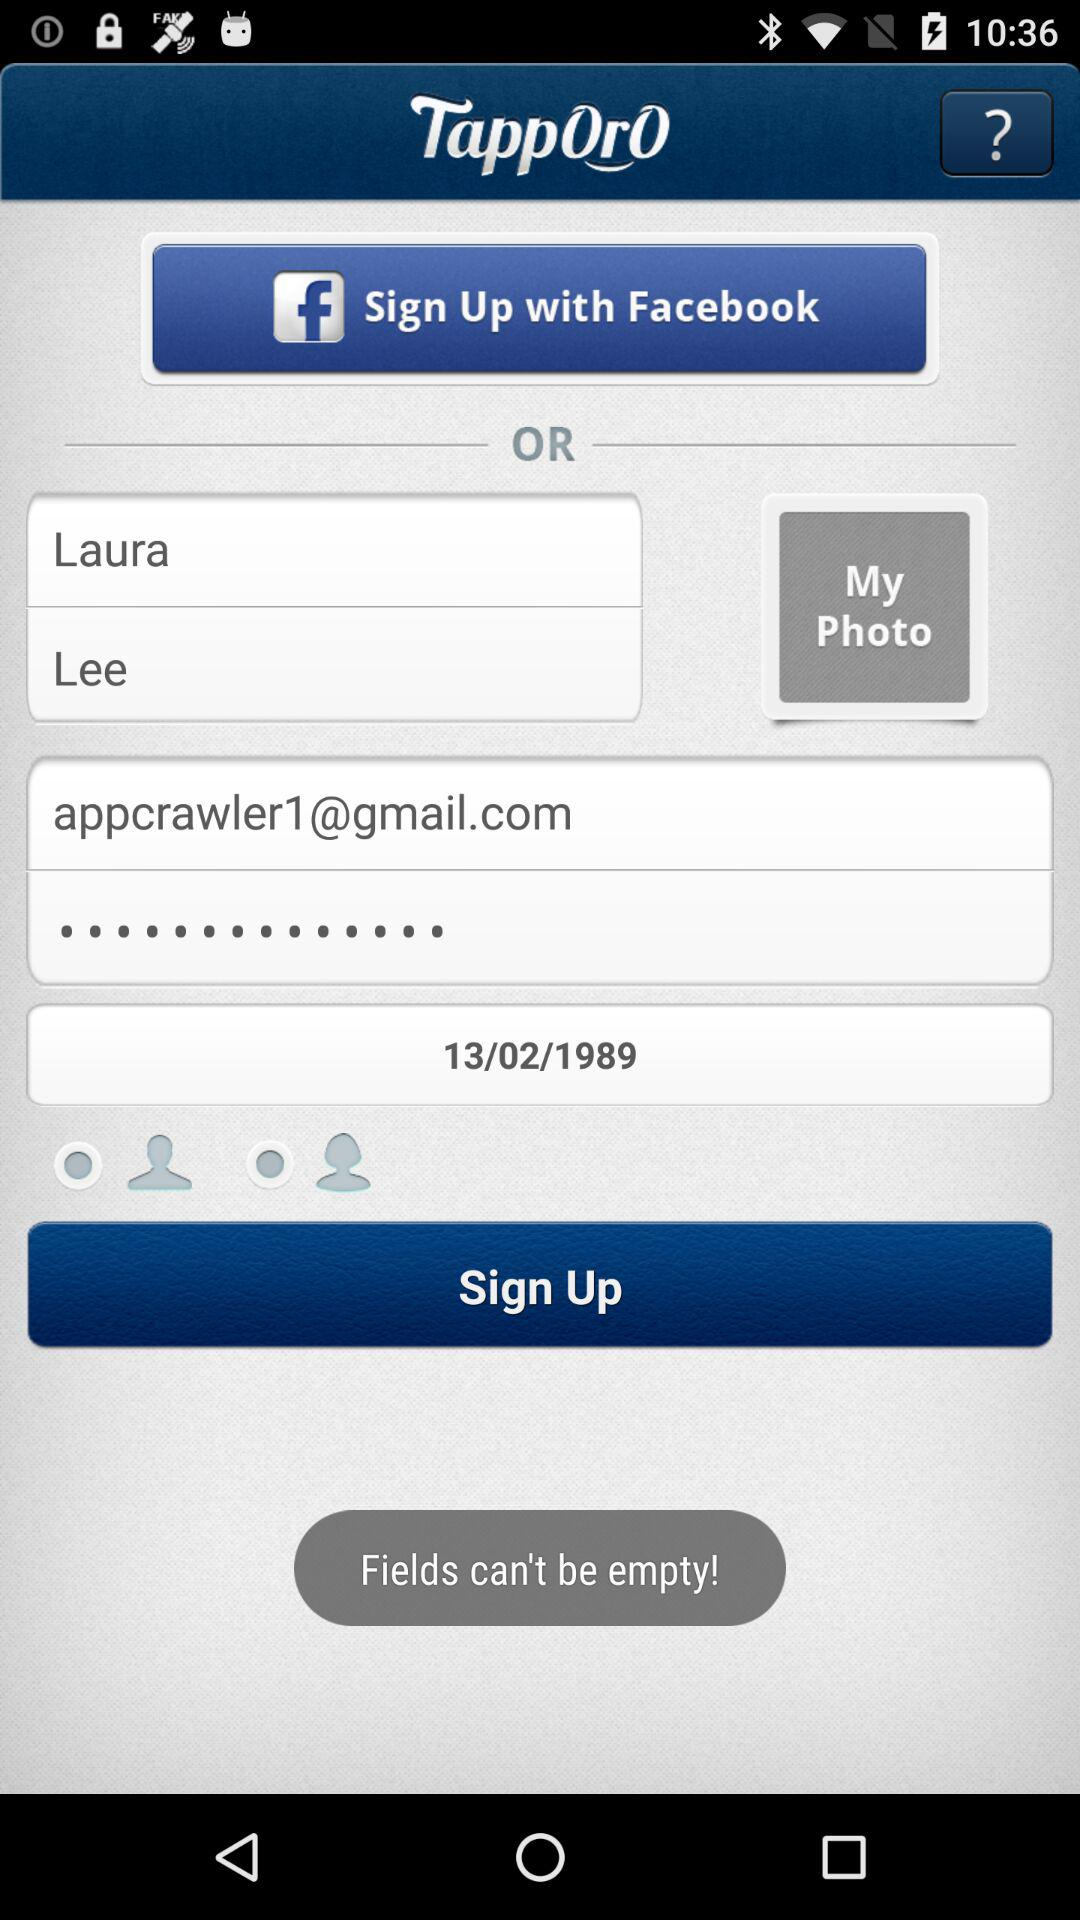What Gmail address can be used for log in? The Gmail address that can be used to log in is appcrawler1@gmail.com. 